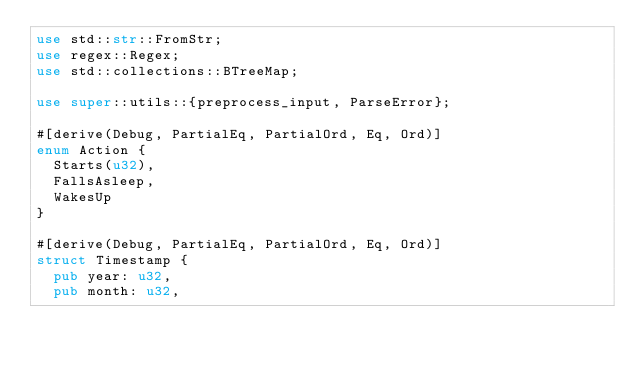<code> <loc_0><loc_0><loc_500><loc_500><_Rust_>use std::str::FromStr;
use regex::Regex;
use std::collections::BTreeMap;

use super::utils::{preprocess_input, ParseError};

#[derive(Debug, PartialEq, PartialOrd, Eq, Ord)]
enum Action {
  Starts(u32),
  FallsAsleep,
  WakesUp
}

#[derive(Debug, PartialEq, PartialOrd, Eq, Ord)]
struct Timestamp {
  pub year: u32,
  pub month: u32,</code> 